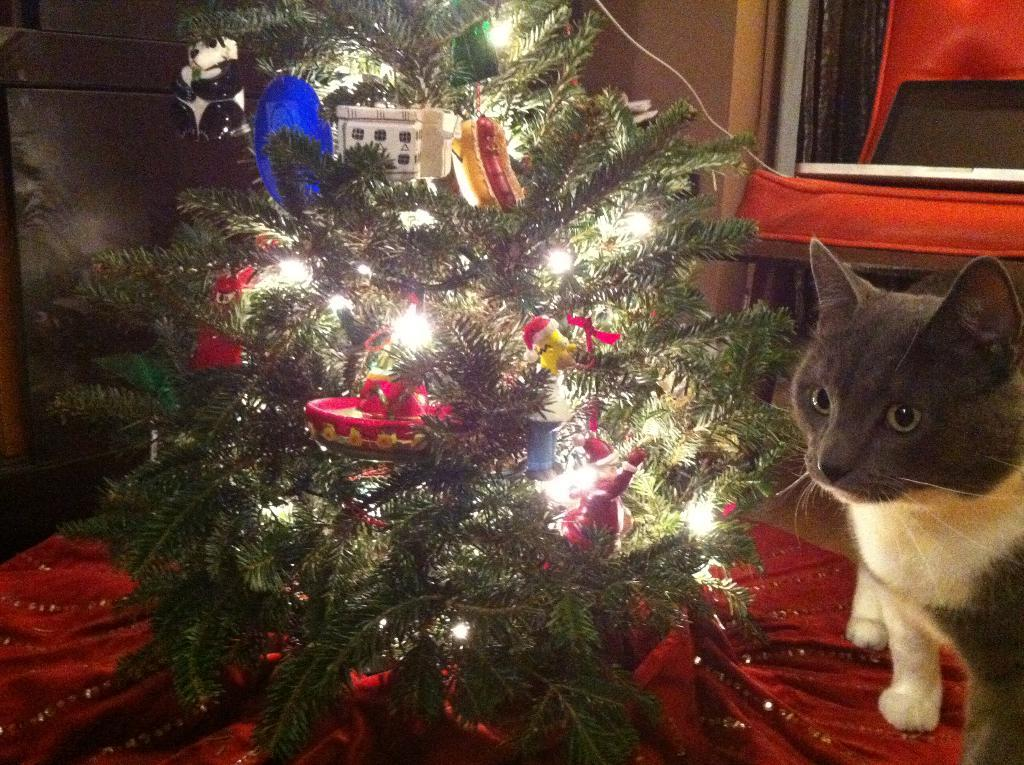What is the main object in the image? There is a Christmas tree in the image. How is the Christmas tree decorated? The Christmas tree is decorated with lights and has dolls on it. Can you describe any other elements in the image? There is a cat on the right side of the image, and it is black and white in color. Where is the mitten located in the image? There is no mitten present in the image. Can you describe the trail that the cat is following in the image? There is no trail visible in the image, and the cat is not following any path. 